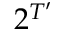<formula> <loc_0><loc_0><loc_500><loc_500>2 ^ { T ^ { \prime } }</formula> 